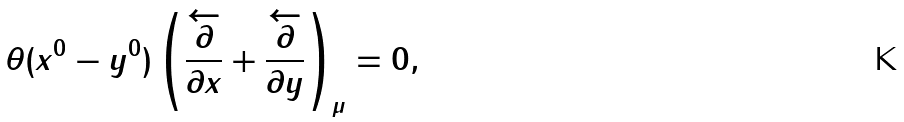<formula> <loc_0><loc_0><loc_500><loc_500>\theta ( x ^ { 0 } - y ^ { 0 } ) \left ( \frac { \overleftarrow { \partial } } { \partial x } + \frac { \overleftarrow { \partial } } { \partial y } \right ) _ { \mu } = 0 ,</formula> 